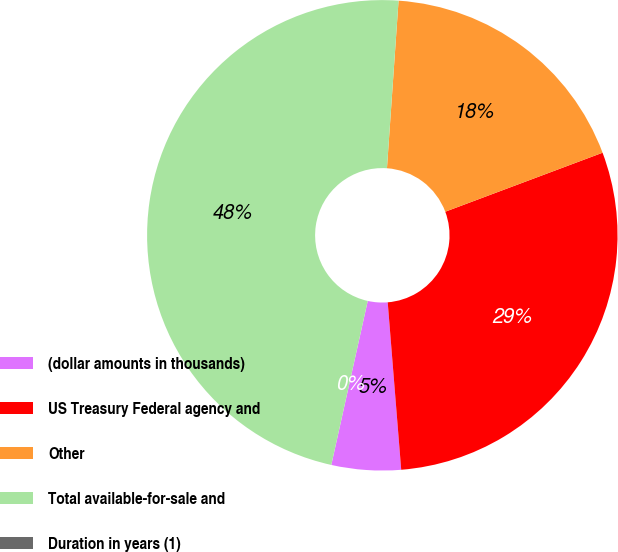Convert chart to OTSL. <chart><loc_0><loc_0><loc_500><loc_500><pie_chart><fcel>(dollar amounts in thousands)<fcel>US Treasury Federal agency and<fcel>Other<fcel>Total available-for-sale and<fcel>Duration in years (1)<nl><fcel>4.76%<fcel>29.43%<fcel>18.19%<fcel>47.62%<fcel>0.0%<nl></chart> 